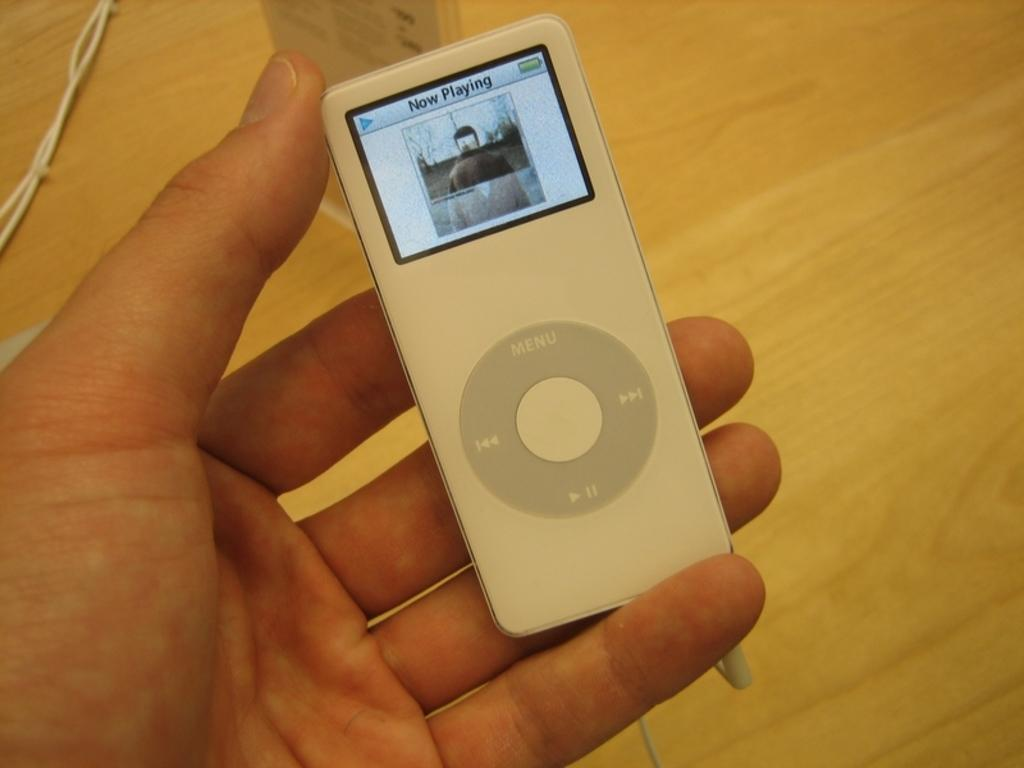What is the person in the image holding? The person is holding an iPod. What can be seen on the table in the image? There is a wooden table in the image. What type of club is the person using to play music in the image? There is no club present in the image, and the person is not playing music. 